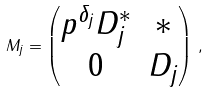Convert formula to latex. <formula><loc_0><loc_0><loc_500><loc_500>M _ { j } = \begin{pmatrix} p ^ { \delta _ { j } } D _ { j } ^ { * } & * \\ 0 & D _ { j } \end{pmatrix} \, ,</formula> 